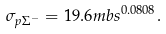<formula> <loc_0><loc_0><loc_500><loc_500>\sigma _ { p \Sigma ^ { - } } = 1 9 . 6 { m b } s ^ { 0 . 0 8 0 8 } .</formula> 